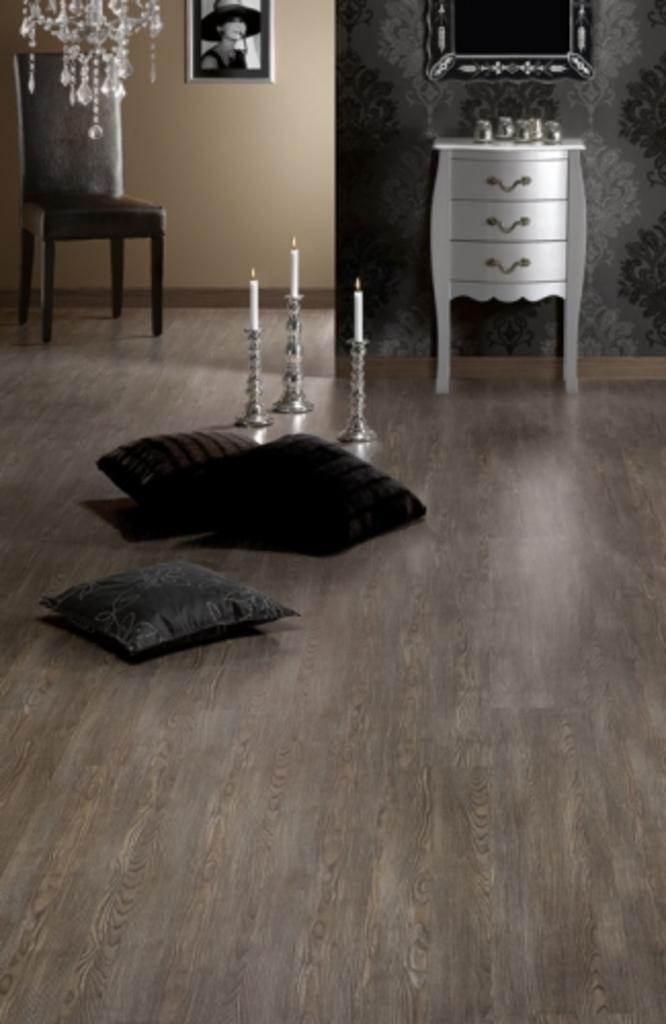Describe this image in one or two sentences. As we can see in the image there is a wall, photo frame, chair, candles, mirror and pillows. 